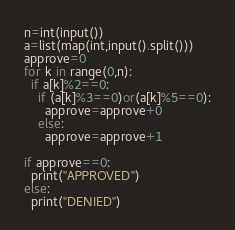Convert code to text. <code><loc_0><loc_0><loc_500><loc_500><_Python_>n=int(input())
a=list(map(int,input().split()))
approve=0
for k in range(0,n):
  if a[k]%2==0:
    if (a[k]%3==0)or(a[k]%5==0):
      approve=approve+0
    else:
      approve=approve+1

if approve==0:
  print("APPROVED")
else:
  print("DENIED")</code> 